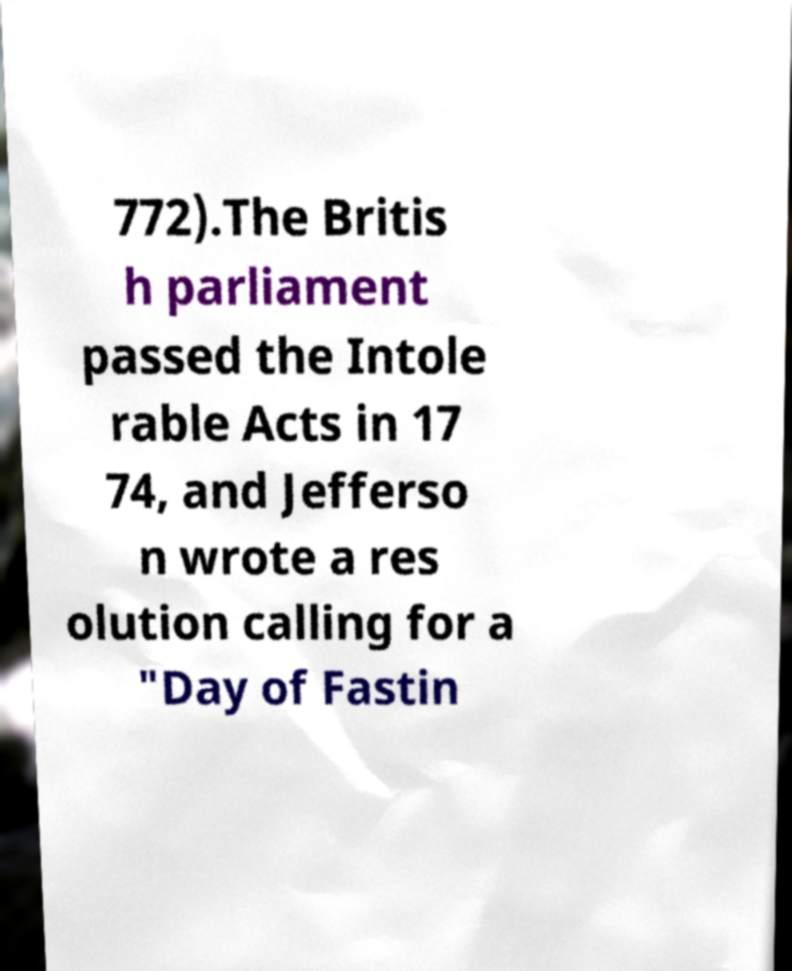Could you extract and type out the text from this image? 772).The Britis h parliament passed the Intole rable Acts in 17 74, and Jefferso n wrote a res olution calling for a "Day of Fastin 